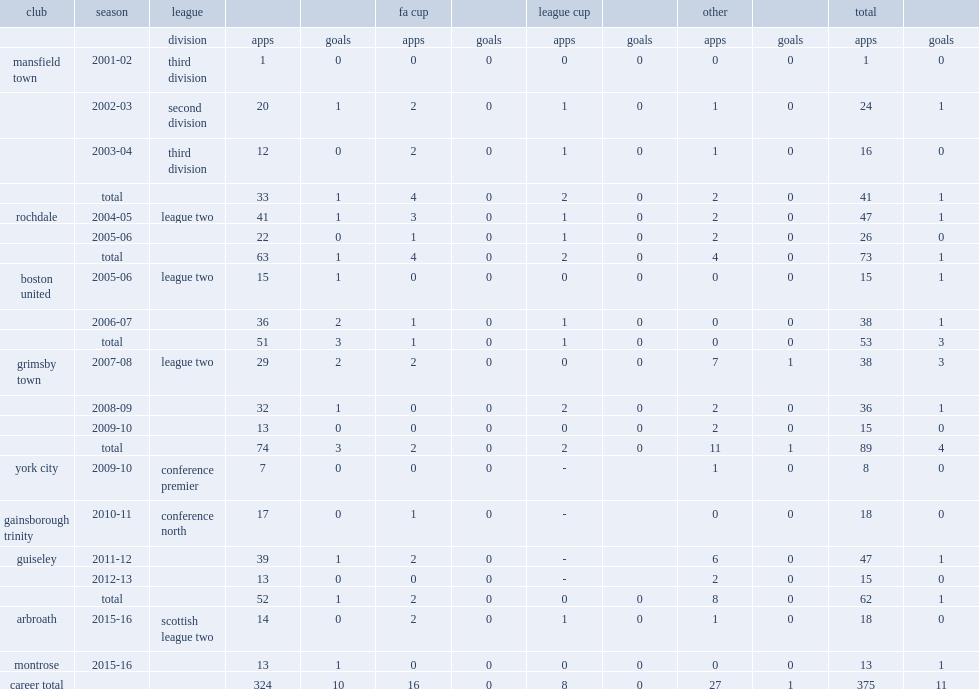Which club did jamie clarke play for in 2011-12? Guiseley. I'm looking to parse the entire table for insights. Could you assist me with that? {'header': ['club', 'season', 'league', '', '', 'fa cup', '', 'league cup', '', 'other', '', 'total', ''], 'rows': [['', '', 'division', 'apps', 'goals', 'apps', 'goals', 'apps', 'goals', 'apps', 'goals', 'apps', 'goals'], ['mansfield town', '2001-02', 'third division', '1', '0', '0', '0', '0', '0', '0', '0', '1', '0'], ['', '2002-03', 'second division', '20', '1', '2', '0', '1', '0', '1', '0', '24', '1'], ['', '2003-04', 'third division', '12', '0', '2', '0', '1', '0', '1', '0', '16', '0'], ['', 'total', '', '33', '1', '4', '0', '2', '0', '2', '0', '41', '1'], ['rochdale', '2004-05', 'league two', '41', '1', '3', '0', '1', '0', '2', '0', '47', '1'], ['', '2005-06', '', '22', '0', '1', '0', '1', '0', '2', '0', '26', '0'], ['', 'total', '', '63', '1', '4', '0', '2', '0', '4', '0', '73', '1'], ['boston united', '2005-06', 'league two', '15', '1', '0', '0', '0', '0', '0', '0', '15', '1'], ['', '2006-07', '', '36', '2', '1', '0', '1', '0', '0', '0', '38', '1'], ['', 'total', '', '51', '3', '1', '0', '1', '0', '0', '0', '53', '3'], ['grimsby town', '2007-08', 'league two', '29', '2', '2', '0', '0', '0', '7', '1', '38', '3'], ['', '2008-09', '', '32', '1', '0', '0', '2', '0', '2', '0', '36', '1'], ['', '2009-10', '', '13', '0', '0', '0', '0', '0', '2', '0', '15', '0'], ['', 'total', '', '74', '3', '2', '0', '2', '0', '11', '1', '89', '4'], ['york city', '2009-10', 'conference premier', '7', '0', '0', '0', '-', '', '1', '0', '8', '0'], ['gainsborough trinity', '2010-11', 'conference north', '17', '0', '1', '0', '-', '', '0', '0', '18', '0'], ['guiseley', '2011-12', '', '39', '1', '2', '0', '-', '', '6', '0', '47', '1'], ['', '2012-13', '', '13', '0', '0', '0', '-', '', '2', '0', '15', '0'], ['', 'total', '', '52', '1', '2', '0', '0', '0', '8', '0', '62', '1'], ['arbroath', '2015-16', 'scottish league two', '14', '0', '2', '0', '1', '0', '1', '0', '18', '0'], ['montrose', '2015-16', '', '13', '1', '0', '0', '0', '0', '0', '0', '13', '1'], ['career total', '', '', '324', '10', '16', '0', '8', '0', '27', '1', '375', '11']]} 